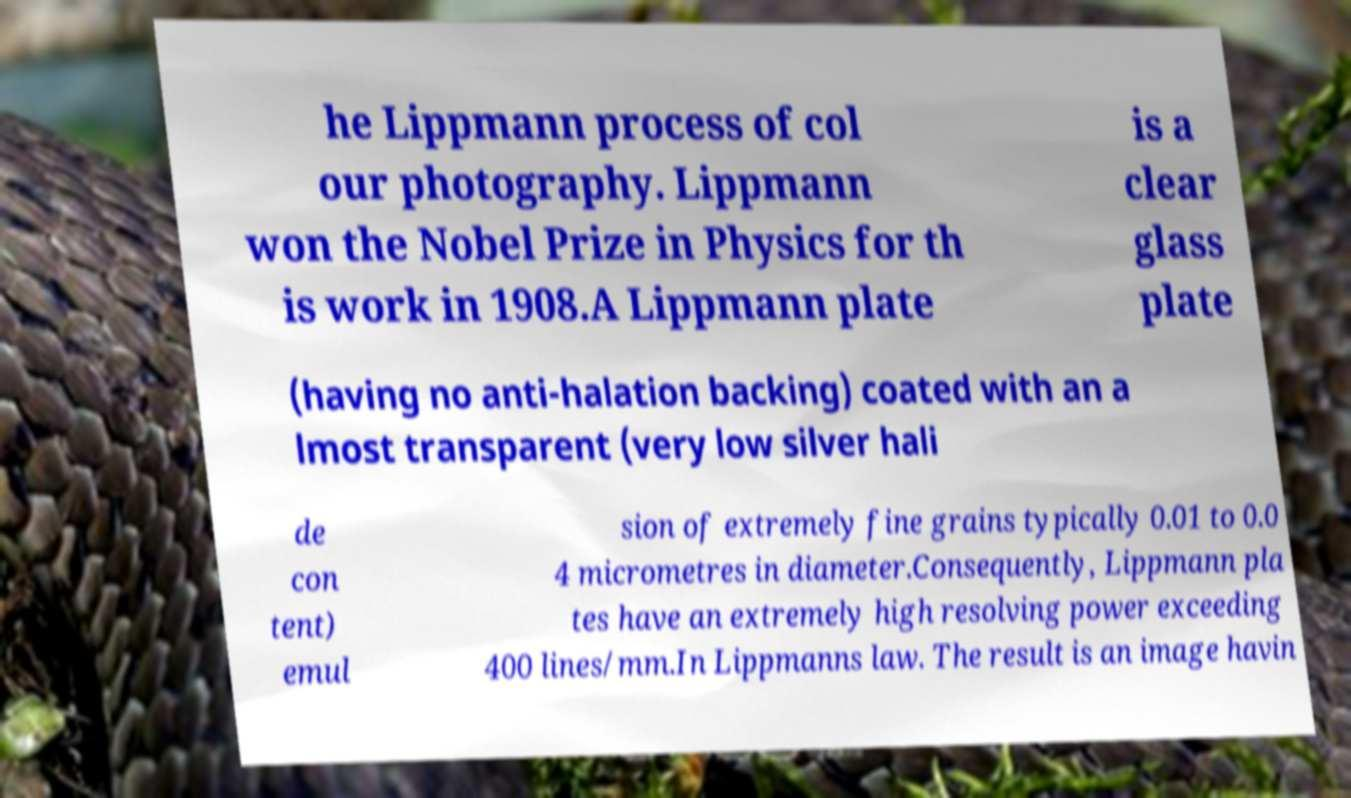Could you assist in decoding the text presented in this image and type it out clearly? he Lippmann process of col our photography. Lippmann won the Nobel Prize in Physics for th is work in 1908.A Lippmann plate is a clear glass plate (having no anti-halation backing) coated with an a lmost transparent (very low silver hali de con tent) emul sion of extremely fine grains typically 0.01 to 0.0 4 micrometres in diameter.Consequently, Lippmann pla tes have an extremely high resolving power exceeding 400 lines/mm.In Lippmanns law. The result is an image havin 